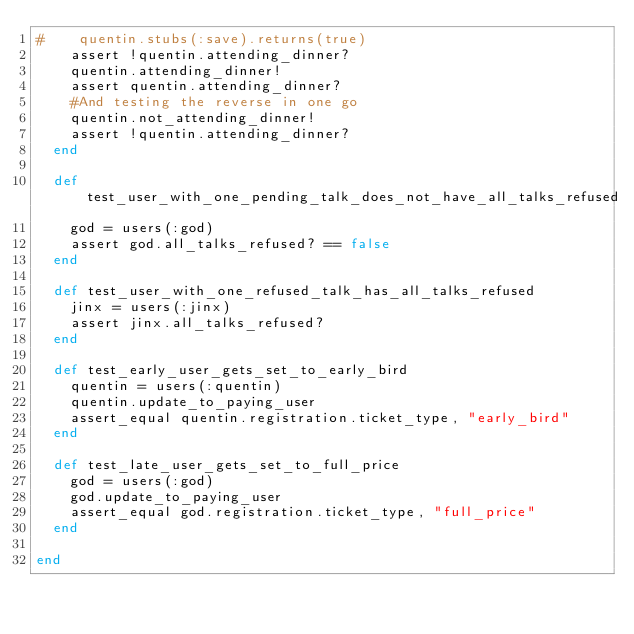<code> <loc_0><loc_0><loc_500><loc_500><_Ruby_>#    quentin.stubs(:save).returns(true)
    assert !quentin.attending_dinner?
    quentin.attending_dinner!
    assert quentin.attending_dinner?
    #And testing the reverse in one go
    quentin.not_attending_dinner!
    assert !quentin.attending_dinner?
  end

  def test_user_with_one_pending_talk_does_not_have_all_talks_refused
    god = users(:god)
    assert god.all_talks_refused? == false
  end

  def test_user_with_one_refused_talk_has_all_talks_refused
    jinx = users(:jinx)
    assert jinx.all_talks_refused?
  end

  def test_early_user_gets_set_to_early_bird
    quentin = users(:quentin)
    quentin.update_to_paying_user
    assert_equal quentin.registration.ticket_type, "early_bird"
  end

  def test_late_user_gets_set_to_full_price
    god = users(:god)
    god.update_to_paying_user
    assert_equal god.registration.ticket_type, "full_price"
  end

end
</code> 